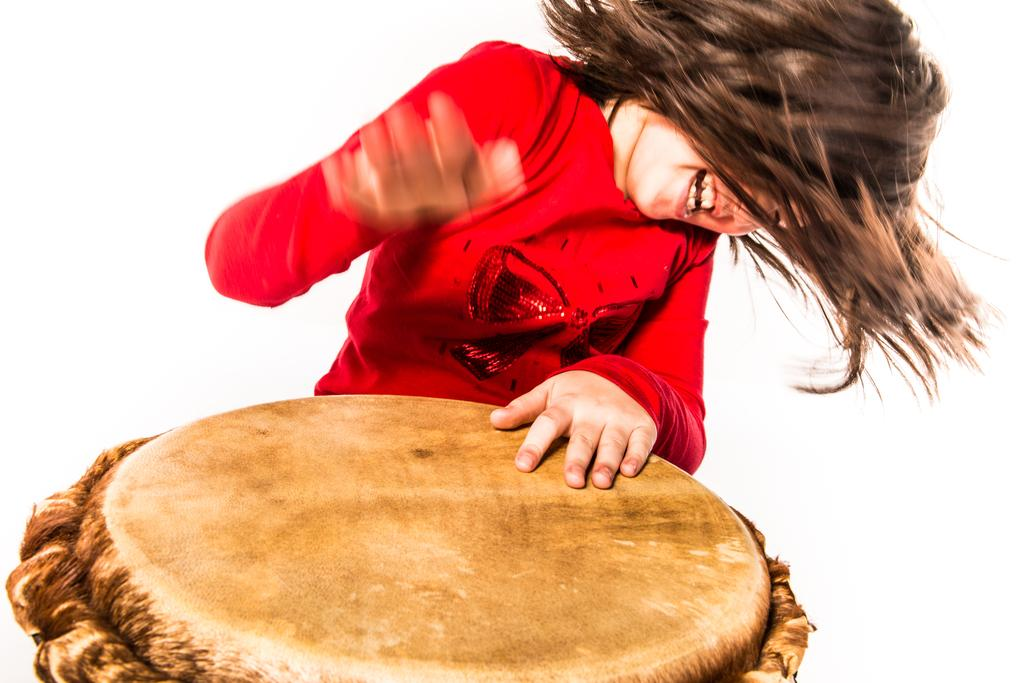Who is present in the image? There is a person in the image. What is the person wearing? The person is wearing a red t-shirt. What object can be seen in the image besides the person? There is a drum in the image. What is the rate of the square in the image? There is no square present in the image, so it is not possible to determine a rate for it. 